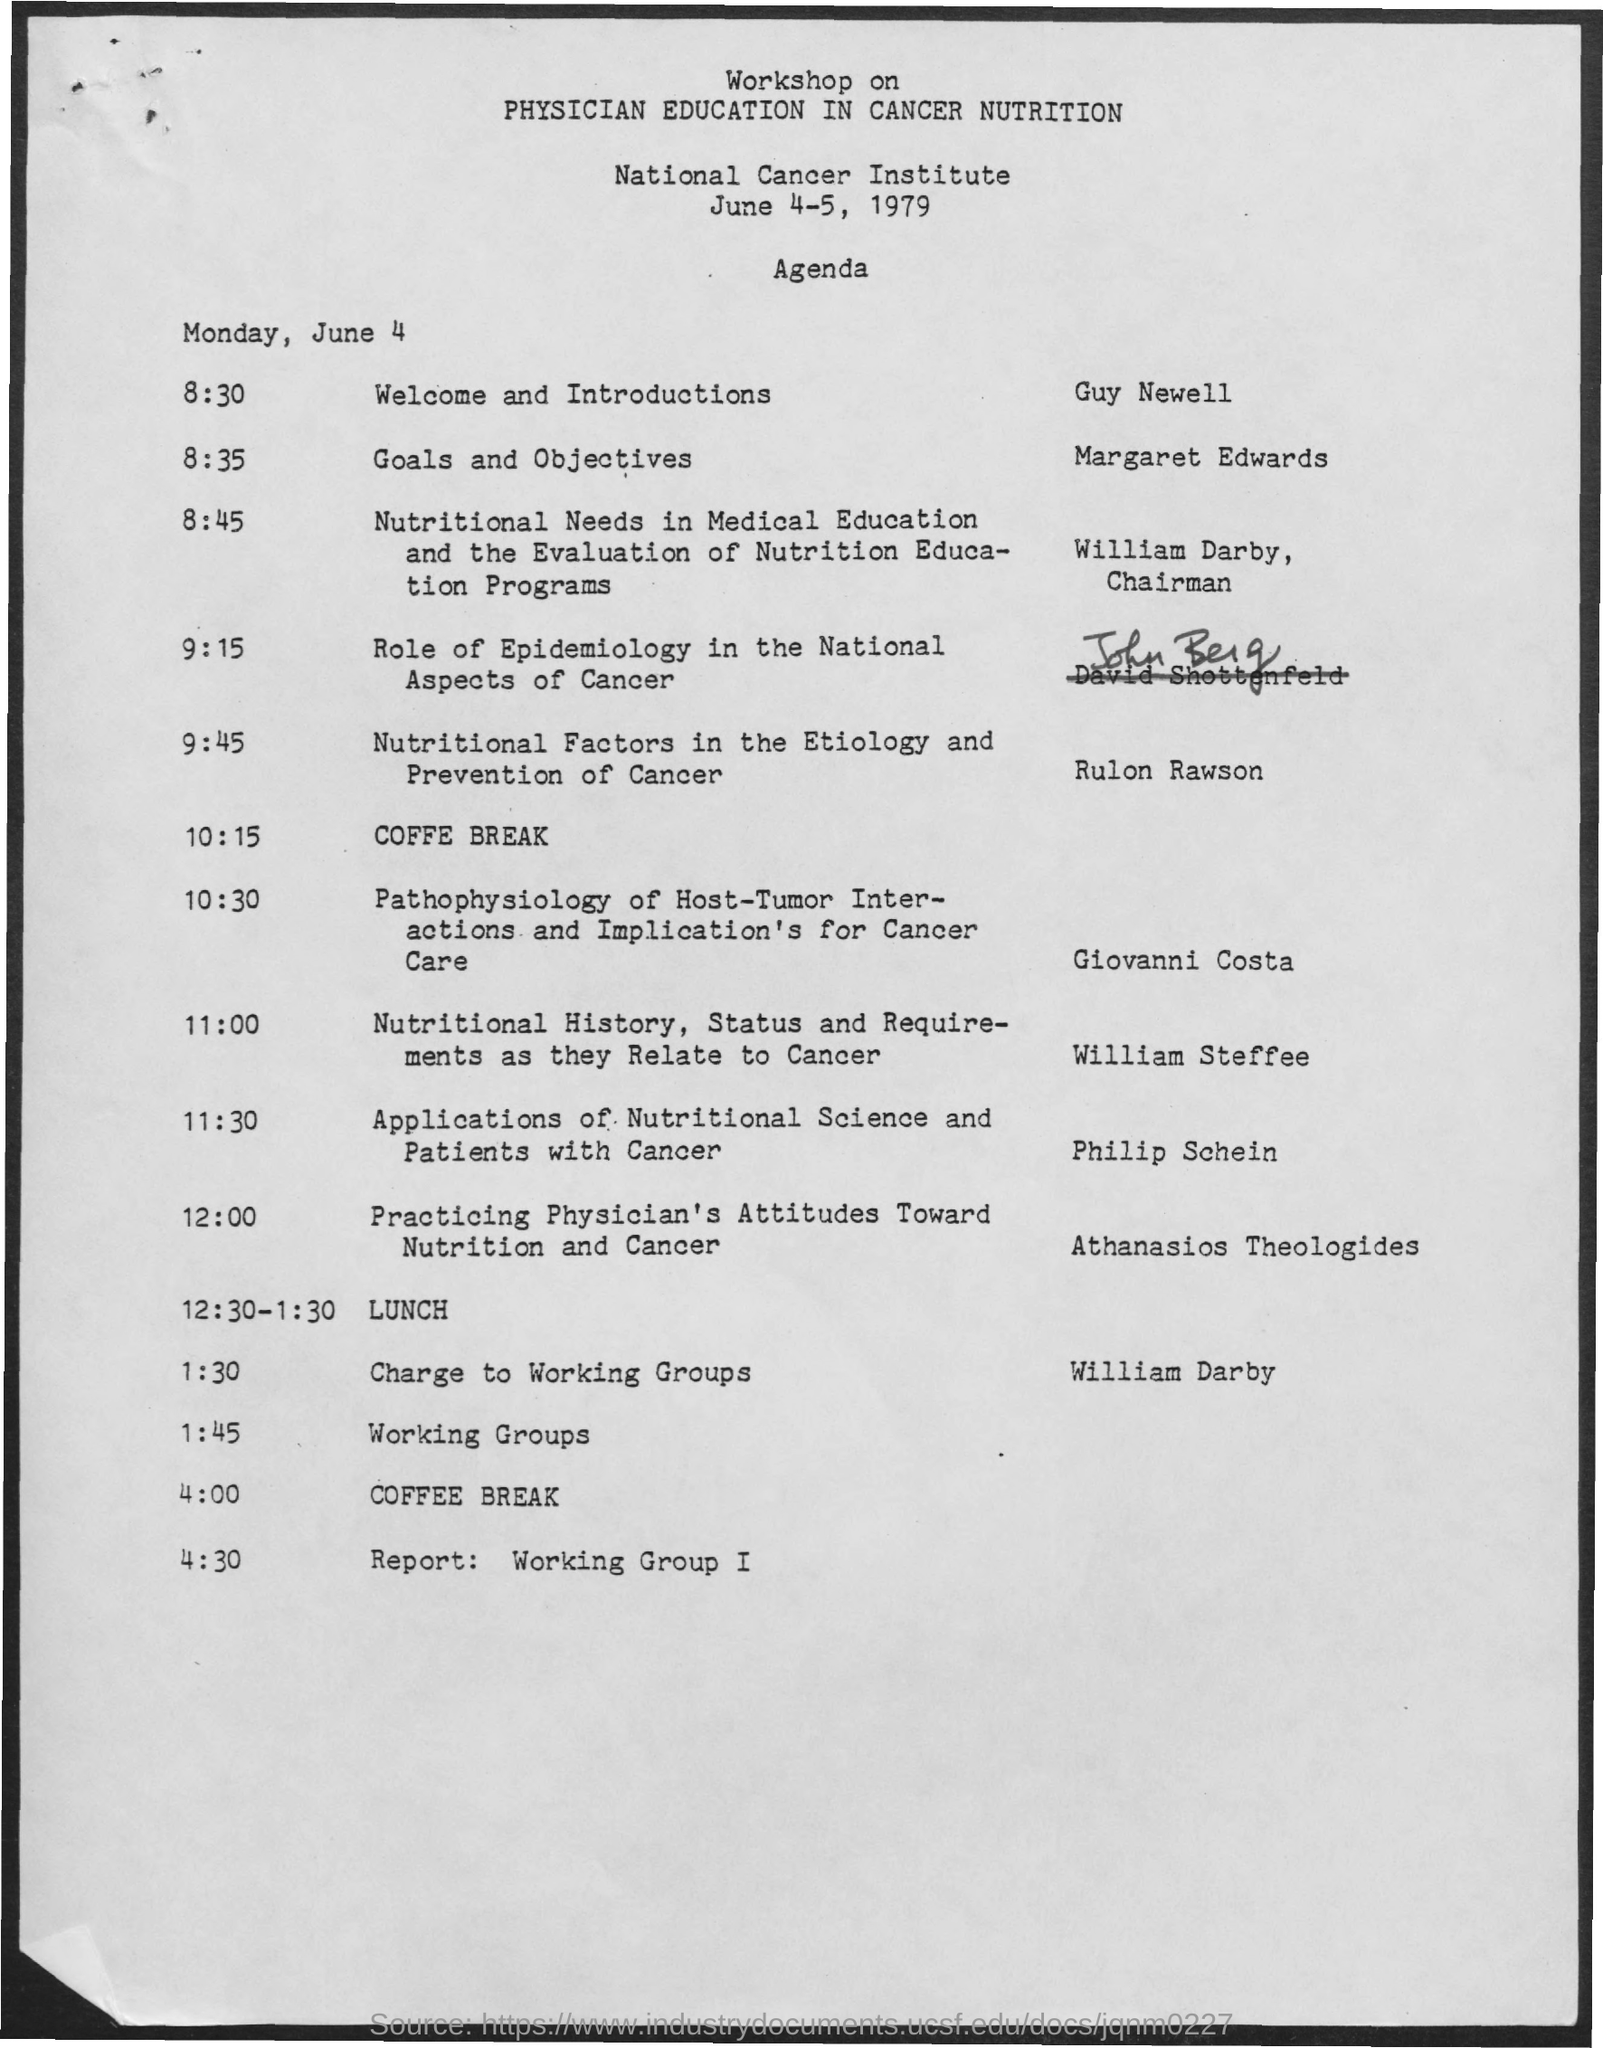Who is the chairman?
Provide a short and direct response. William Darby. After the lunch,workshop is on which topic?
Provide a succinct answer. Charge to working groups. After the lunch,workshop is conducted by whom?
Offer a terse response. William Darby. 